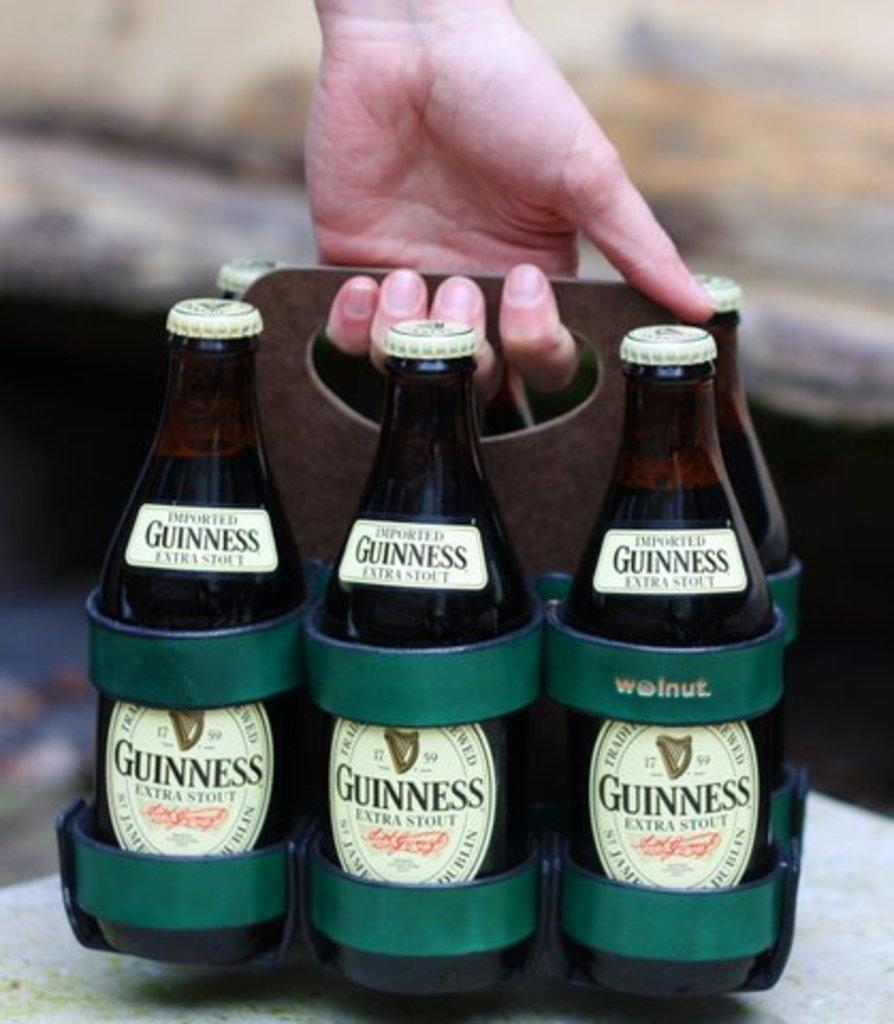What is the person's hand holding in the image? The person's hand is holding bottles in the image. What can be seen on the bottles? The bottles have stickers on them. What information is provided on the stickers? There are words on the stickers. How many trucks are parked at the plantation in the image? There is no mention of trucks or a plantation in the image; it only shows a person's hand holding bottles with stickers on them. 